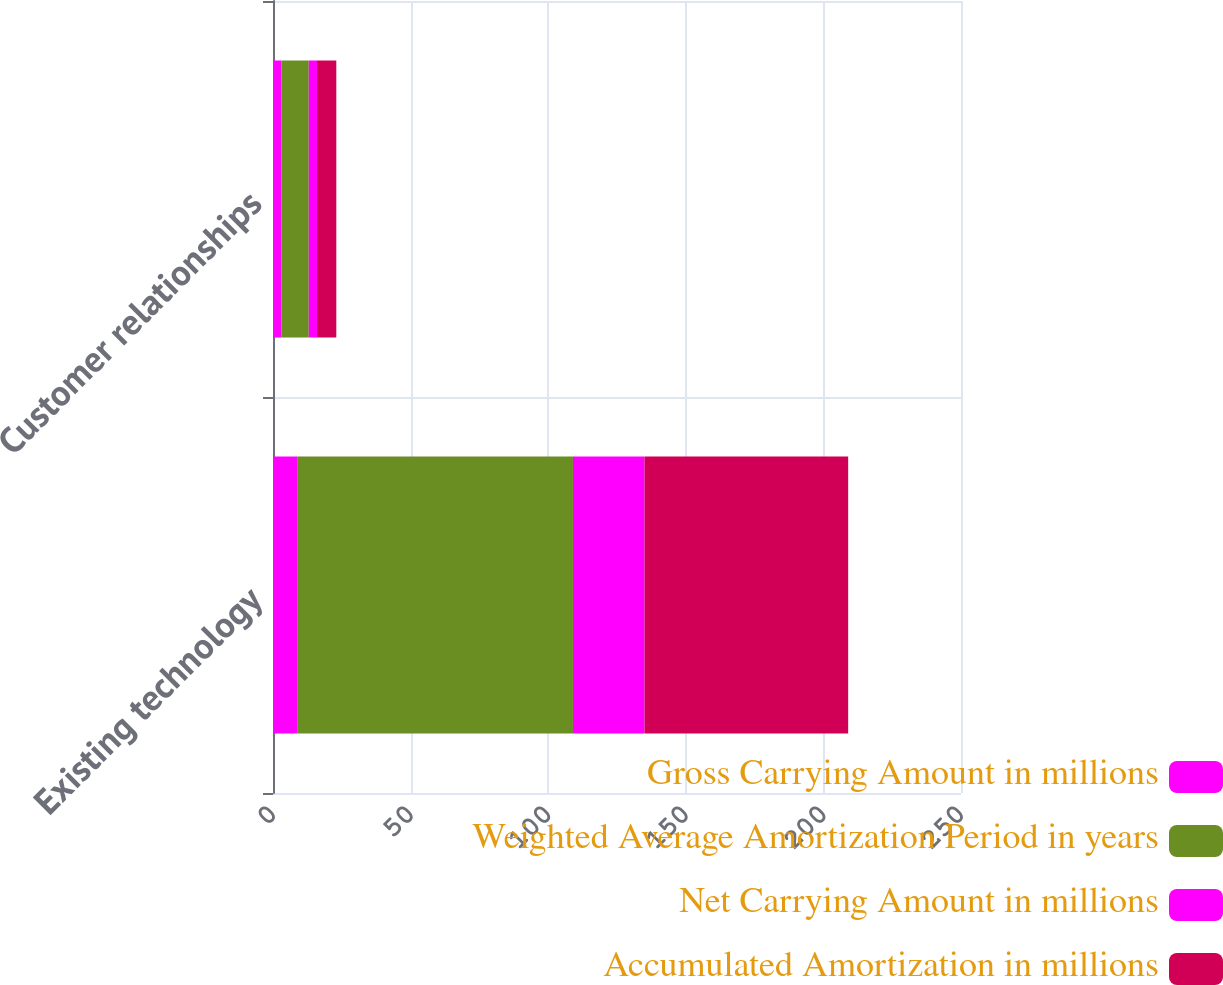<chart> <loc_0><loc_0><loc_500><loc_500><stacked_bar_chart><ecel><fcel>Existing technology<fcel>Customer relationships<nl><fcel>Gross Carrying Amount in millions<fcel>9<fcel>3<nl><fcel>Weighted Average Amortization Period in years<fcel>100<fcel>10<nl><fcel>Net Carrying Amount in millions<fcel>26<fcel>3<nl><fcel>Accumulated Amortization in millions<fcel>74<fcel>7<nl></chart> 